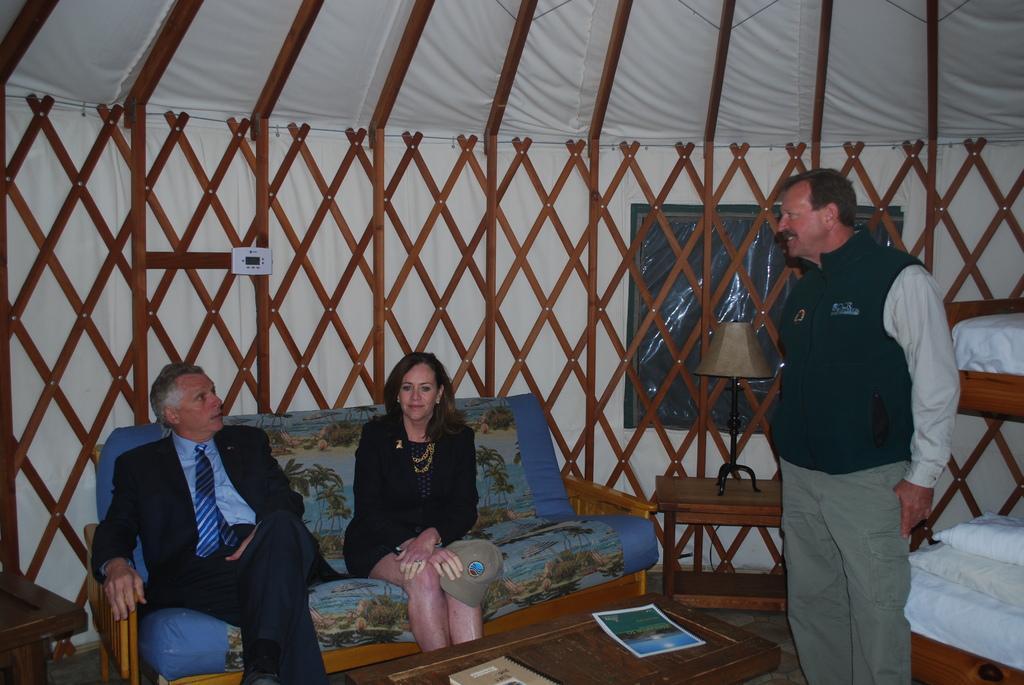In one or two sentences, can you explain what this image depicts? A man wearing coat and lady wearing a black dress holding cap and sitting on a sofa. A man standing there. Behind them there is a wooden railing. There is a table. On the table there are books. 